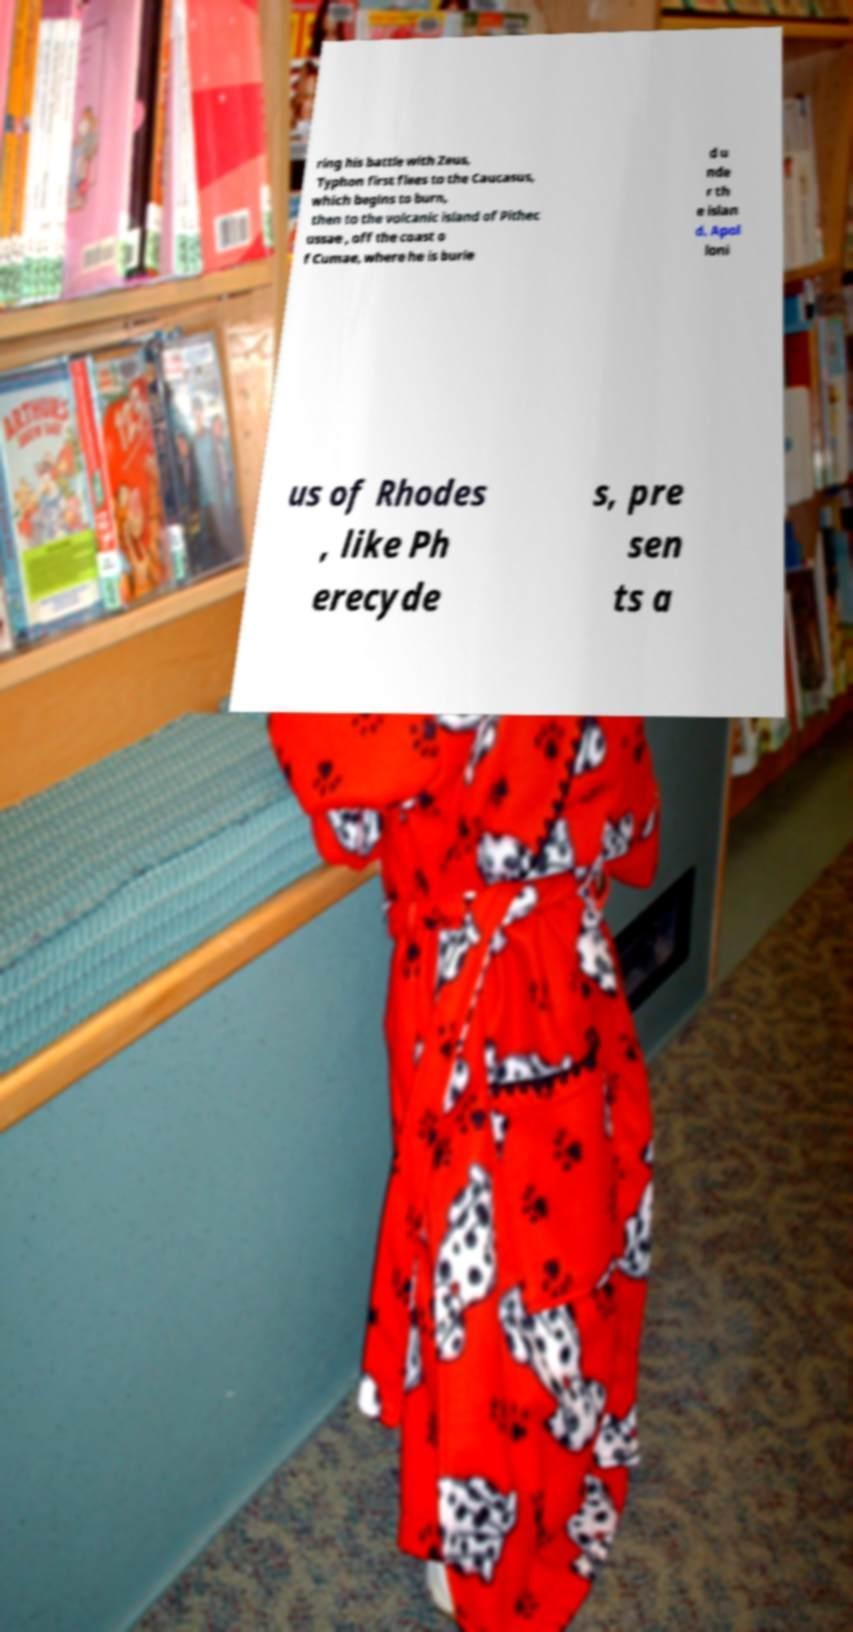I need the written content from this picture converted into text. Can you do that? ring his battle with Zeus, Typhon first flees to the Caucasus, which begins to burn, then to the volcanic island of Pithec ussae , off the coast o f Cumae, where he is burie d u nde r th e islan d. Apol loni us of Rhodes , like Ph erecyde s, pre sen ts a 